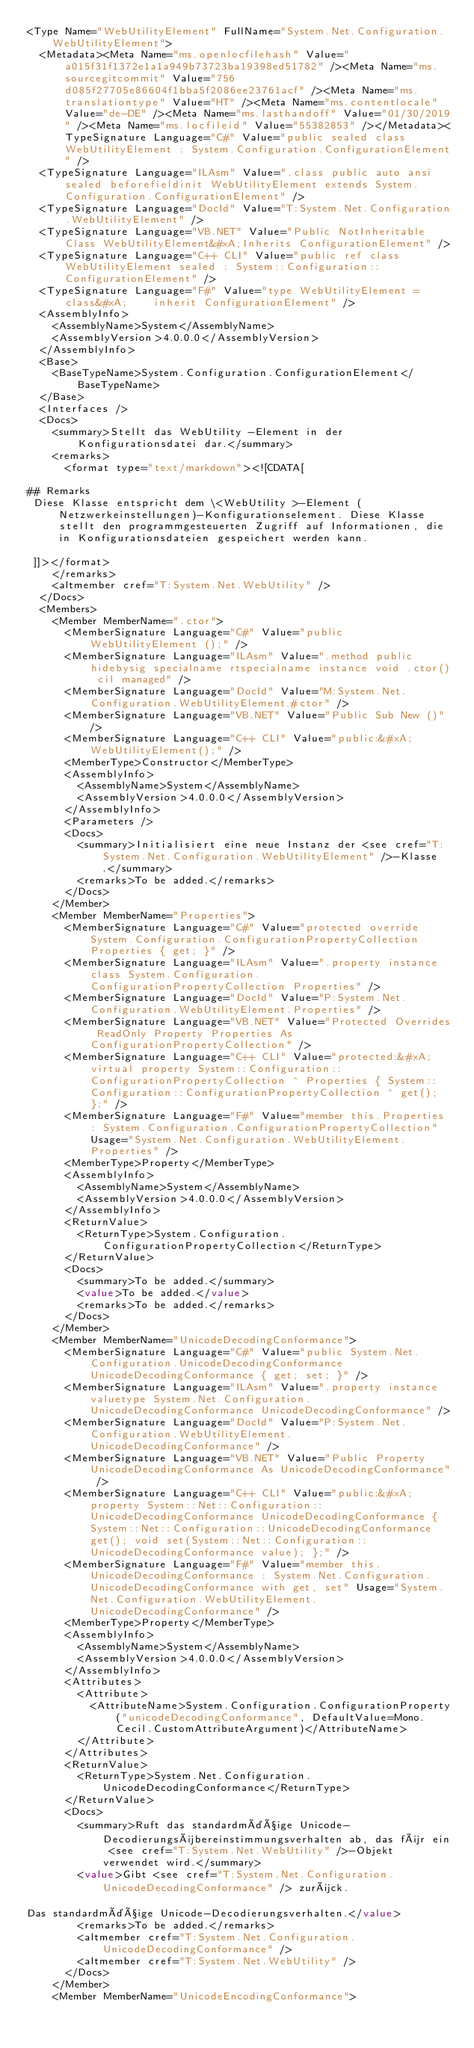Convert code to text. <code><loc_0><loc_0><loc_500><loc_500><_XML_><Type Name="WebUtilityElement" FullName="System.Net.Configuration.WebUtilityElement">
  <Metadata><Meta Name="ms.openlocfilehash" Value="a015f31f1372e1a1a949b73723ba19398ed51782" /><Meta Name="ms.sourcegitcommit" Value="756d085f27705e86604f1bba5f2086ee23761acf" /><Meta Name="ms.translationtype" Value="HT" /><Meta Name="ms.contentlocale" Value="de-DE" /><Meta Name="ms.lasthandoff" Value="01/30/2019" /><Meta Name="ms.locfileid" Value="55382853" /></Metadata><TypeSignature Language="C#" Value="public sealed class WebUtilityElement : System.Configuration.ConfigurationElement" />
  <TypeSignature Language="ILAsm" Value=".class public auto ansi sealed beforefieldinit WebUtilityElement extends System.Configuration.ConfigurationElement" />
  <TypeSignature Language="DocId" Value="T:System.Net.Configuration.WebUtilityElement" />
  <TypeSignature Language="VB.NET" Value="Public NotInheritable Class WebUtilityElement&#xA;Inherits ConfigurationElement" />
  <TypeSignature Language="C++ CLI" Value="public ref class WebUtilityElement sealed : System::Configuration::ConfigurationElement" />
  <TypeSignature Language="F#" Value="type WebUtilityElement = class&#xA;    inherit ConfigurationElement" />
  <AssemblyInfo>
    <AssemblyName>System</AssemblyName>
    <AssemblyVersion>4.0.0.0</AssemblyVersion>
  </AssemblyInfo>
  <Base>
    <BaseTypeName>System.Configuration.ConfigurationElement</BaseTypeName>
  </Base>
  <Interfaces />
  <Docs>
    <summary>Stellt das WebUtility -Element in der Konfigurationsdatei dar.</summary>
    <remarks>
      <format type="text/markdown"><![CDATA[  
  
## Remarks  
 Diese Klasse entspricht dem \<WebUtility >-Element (Netzwerkeinstellungen)-Konfigurationselement. Diese Klasse stellt den programmgesteuerten Zugriff auf Informationen, die in Konfigurationsdateien gespeichert werden kann.  
  
 ]]></format>
    </remarks>
    <altmember cref="T:System.Net.WebUtility" />
  </Docs>
  <Members>
    <Member MemberName=".ctor">
      <MemberSignature Language="C#" Value="public WebUtilityElement ();" />
      <MemberSignature Language="ILAsm" Value=".method public hidebysig specialname rtspecialname instance void .ctor() cil managed" />
      <MemberSignature Language="DocId" Value="M:System.Net.Configuration.WebUtilityElement.#ctor" />
      <MemberSignature Language="VB.NET" Value="Public Sub New ()" />
      <MemberSignature Language="C++ CLI" Value="public:&#xA; WebUtilityElement();" />
      <MemberType>Constructor</MemberType>
      <AssemblyInfo>
        <AssemblyName>System</AssemblyName>
        <AssemblyVersion>4.0.0.0</AssemblyVersion>
      </AssemblyInfo>
      <Parameters />
      <Docs>
        <summary>Initialisiert eine neue Instanz der <see cref="T:System.Net.Configuration.WebUtilityElement" />-Klasse.</summary>
        <remarks>To be added.</remarks>
      </Docs>
    </Member>
    <Member MemberName="Properties">
      <MemberSignature Language="C#" Value="protected override System.Configuration.ConfigurationPropertyCollection Properties { get; }" />
      <MemberSignature Language="ILAsm" Value=".property instance class System.Configuration.ConfigurationPropertyCollection Properties" />
      <MemberSignature Language="DocId" Value="P:System.Net.Configuration.WebUtilityElement.Properties" />
      <MemberSignature Language="VB.NET" Value="Protected Overrides ReadOnly Property Properties As ConfigurationPropertyCollection" />
      <MemberSignature Language="C++ CLI" Value="protected:&#xA; virtual property System::Configuration::ConfigurationPropertyCollection ^ Properties { System::Configuration::ConfigurationPropertyCollection ^ get(); };" />
      <MemberSignature Language="F#" Value="member this.Properties : System.Configuration.ConfigurationPropertyCollection" Usage="System.Net.Configuration.WebUtilityElement.Properties" />
      <MemberType>Property</MemberType>
      <AssemblyInfo>
        <AssemblyName>System</AssemblyName>
        <AssemblyVersion>4.0.0.0</AssemblyVersion>
      </AssemblyInfo>
      <ReturnValue>
        <ReturnType>System.Configuration.ConfigurationPropertyCollection</ReturnType>
      </ReturnValue>
      <Docs>
        <summary>To be added.</summary>
        <value>To be added.</value>
        <remarks>To be added.</remarks>
      </Docs>
    </Member>
    <Member MemberName="UnicodeDecodingConformance">
      <MemberSignature Language="C#" Value="public System.Net.Configuration.UnicodeDecodingConformance UnicodeDecodingConformance { get; set; }" />
      <MemberSignature Language="ILAsm" Value=".property instance valuetype System.Net.Configuration.UnicodeDecodingConformance UnicodeDecodingConformance" />
      <MemberSignature Language="DocId" Value="P:System.Net.Configuration.WebUtilityElement.UnicodeDecodingConformance" />
      <MemberSignature Language="VB.NET" Value="Public Property UnicodeDecodingConformance As UnicodeDecodingConformance" />
      <MemberSignature Language="C++ CLI" Value="public:&#xA; property System::Net::Configuration::UnicodeDecodingConformance UnicodeDecodingConformance { System::Net::Configuration::UnicodeDecodingConformance get(); void set(System::Net::Configuration::UnicodeDecodingConformance value); };" />
      <MemberSignature Language="F#" Value="member this.UnicodeDecodingConformance : System.Net.Configuration.UnicodeDecodingConformance with get, set" Usage="System.Net.Configuration.WebUtilityElement.UnicodeDecodingConformance" />
      <MemberType>Property</MemberType>
      <AssemblyInfo>
        <AssemblyName>System</AssemblyName>
        <AssemblyVersion>4.0.0.0</AssemblyVersion>
      </AssemblyInfo>
      <Attributes>
        <Attribute>
          <AttributeName>System.Configuration.ConfigurationProperty("unicodeDecodingConformance", DefaultValue=Mono.Cecil.CustomAttributeArgument)</AttributeName>
        </Attribute>
      </Attributes>
      <ReturnValue>
        <ReturnType>System.Net.Configuration.UnicodeDecodingConformance</ReturnType>
      </ReturnValue>
      <Docs>
        <summary>Ruft das standardmäßige Unicode-Decodierungsübereinstimmungsverhalten ab, das für ein <see cref="T:System.Net.WebUtility" />-Objekt verwendet wird.</summary>
        <value>Gibt <see cref="T:System.Net.Configuration.UnicodeDecodingConformance" /> zurück.  
  
Das standardmäßige Unicode-Decodierungsverhalten.</value>
        <remarks>To be added.</remarks>
        <altmember cref="T:System.Net.Configuration.UnicodeDecodingConformance" />
        <altmember cref="T:System.Net.WebUtility" />
      </Docs>
    </Member>
    <Member MemberName="UnicodeEncodingConformance"></code> 